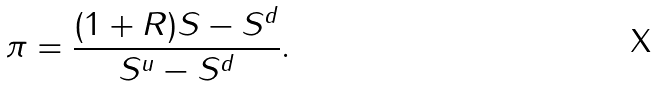<formula> <loc_0><loc_0><loc_500><loc_500>\pi = { \frac { ( 1 + R ) S - S ^ { d } } { S ^ { u } - S ^ { d } } } .</formula> 